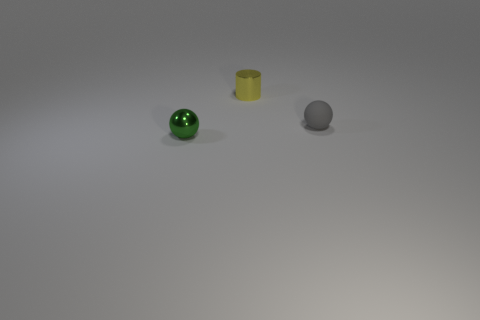What textures can you observe on the objects and what does that suggest about the material they might be made of? The green sphere has a smooth and reflective surface suggesting it might be made of glass or polished metal, the yellow cylinder has a more dull and consistent color resembling plastic, and the gray sphere has a slightly uneven surface which could imply it's made of stone or a coated material. 